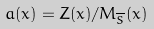Convert formula to latex. <formula><loc_0><loc_0><loc_500><loc_500>a ( x ) = Z ( x ) / M _ { \overline { S } } ( x )</formula> 